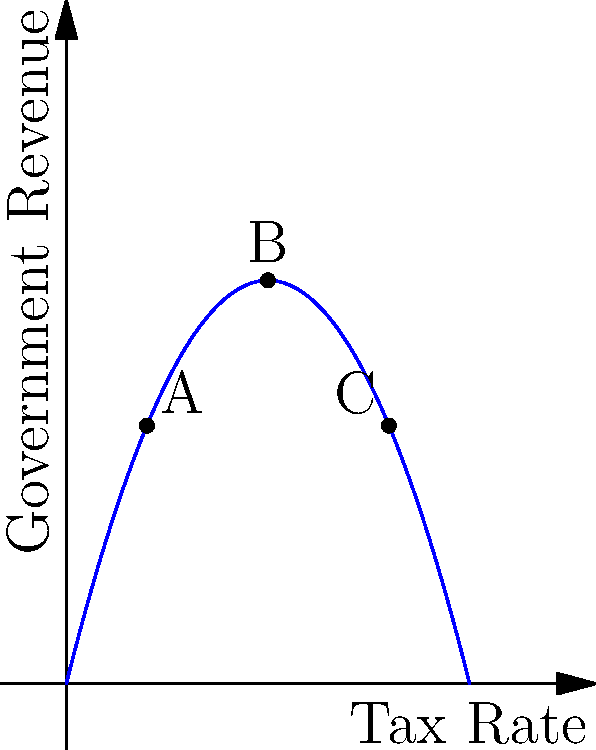The graph above represents a simplified Laffer curve, showing the relationship between tax rates and government revenue. Points A, B, and C represent different tax rate scenarios. Which point represents the optimal tax rate for maximizing government revenue, and how would you explain this to critics who argue for either very low or very high tax rates? To answer this question, we need to analyze the Laffer curve and understand its implications:

1. The Laffer curve is represented by the polynomial function $f(x) = -4x^2 + 4x$, where $x$ is the tax rate and $f(x)$ is the government revenue.

2. Point A represents a low tax rate scenario (approximately 20%).
   Point B represents a moderate tax rate scenario (50%).
   Point C represents a high tax rate scenario (approximately 80%).

3. The vertex of the parabola represents the optimal tax rate for maximizing government revenue. This occurs at point B (50% tax rate).

4. To find the vertex mathematically:
   $f'(x) = -8x + 4$
   Set $f'(x) = 0$: $-8x + 4 = 0$
   Solve for $x$: $x = 0.5$ or 50%

5. Explanation for critics:
   - For low tax rate advocates: While low taxes can stimulate economic activity, they may not generate sufficient revenue for essential government functions.
   - For high tax rate advocates: Excessive taxation can discourage economic activity, leading to reduced overall revenue despite higher rates.

6. The optimal rate (B) balances these competing effects, maximizing revenue while maintaining economic incentives.
Answer: Point B (50% tax rate) maximizes revenue; it balances economic incentives and government funding needs. 